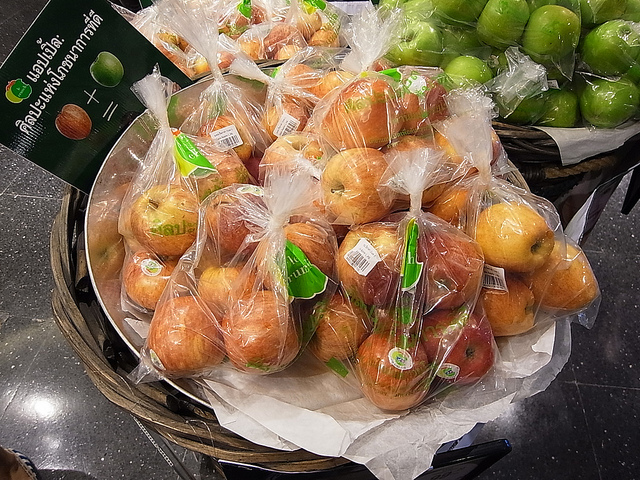<image>What language is shown? I am not sure what language is shown. It could be any number of languages, including Korean, Russian, Arabic, Tamil, Thai, or Hindi. What language is shown? I don't know what language is shown. It can be Islam, Korean, Russian, Arabic, Tamil, Thai, or Hindi. 